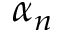<formula> <loc_0><loc_0><loc_500><loc_500>\alpha _ { n }</formula> 